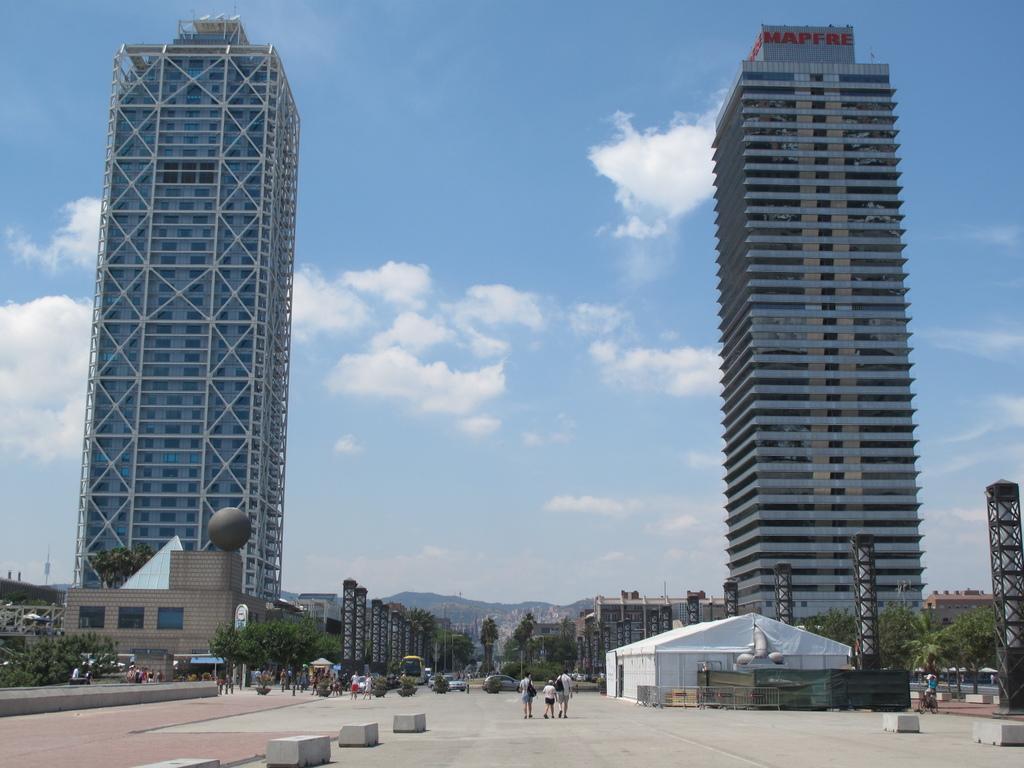Could you give a brief overview of what you see in this image? In this image there are people walking on the road. There are vehicles. In the background of the image there are trees, buildings, mountains and sky. In front of the image there are concrete benches. 